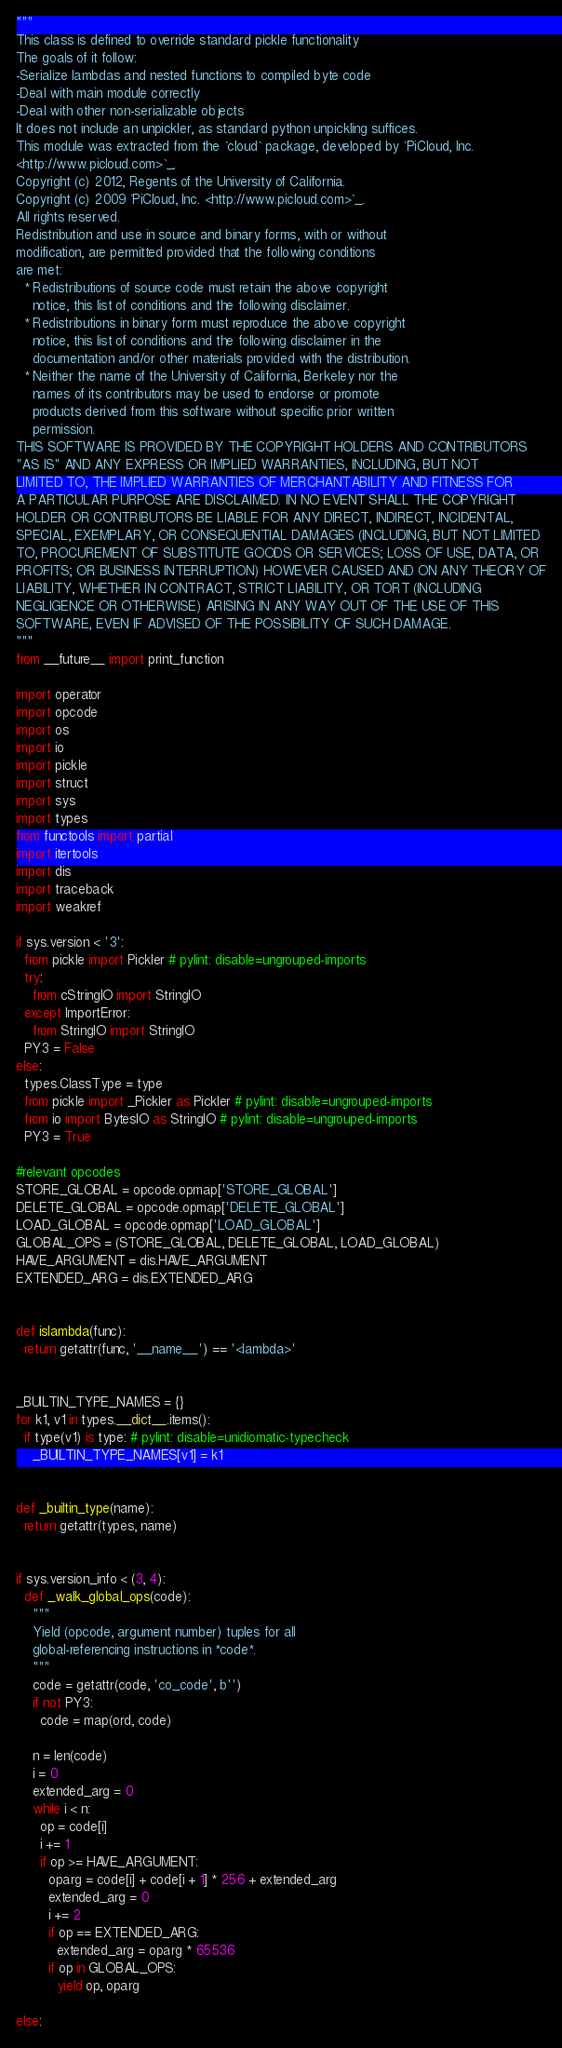<code> <loc_0><loc_0><loc_500><loc_500><_Python_>"""
This class is defined to override standard pickle functionality
The goals of it follow:
-Serialize lambdas and nested functions to compiled byte code
-Deal with main module correctly
-Deal with other non-serializable objects
It does not include an unpickler, as standard python unpickling suffices.
This module was extracted from the `cloud` package, developed by `PiCloud, Inc.
<http://www.picloud.com>`_.
Copyright (c) 2012, Regents of the University of California.
Copyright (c) 2009 `PiCloud, Inc. <http://www.picloud.com>`_.
All rights reserved.
Redistribution and use in source and binary forms, with or without
modification, are permitted provided that the following conditions
are met:
  * Redistributions of source code must retain the above copyright
    notice, this list of conditions and the following disclaimer.
  * Redistributions in binary form must reproduce the above copyright
    notice, this list of conditions and the following disclaimer in the
    documentation and/or other materials provided with the distribution.
  * Neither the name of the University of California, Berkeley nor the
    names of its contributors may be used to endorse or promote
    products derived from this software without specific prior written
    permission.
THIS SOFTWARE IS PROVIDED BY THE COPYRIGHT HOLDERS AND CONTRIBUTORS
"AS IS" AND ANY EXPRESS OR IMPLIED WARRANTIES, INCLUDING, BUT NOT
LIMITED TO, THE IMPLIED WARRANTIES OF MERCHANTABILITY AND FITNESS FOR
A PARTICULAR PURPOSE ARE DISCLAIMED. IN NO EVENT SHALL THE COPYRIGHT
HOLDER OR CONTRIBUTORS BE LIABLE FOR ANY DIRECT, INDIRECT, INCIDENTAL,
SPECIAL, EXEMPLARY, OR CONSEQUENTIAL DAMAGES (INCLUDING, BUT NOT LIMITED
TO, PROCUREMENT OF SUBSTITUTE GOODS OR SERVICES; LOSS OF USE, DATA, OR
PROFITS; OR BUSINESS INTERRUPTION) HOWEVER CAUSED AND ON ANY THEORY OF
LIABILITY, WHETHER IN CONTRACT, STRICT LIABILITY, OR TORT (INCLUDING
NEGLIGENCE OR OTHERWISE) ARISING IN ANY WAY OUT OF THE USE OF THIS
SOFTWARE, EVEN IF ADVISED OF THE POSSIBILITY OF SUCH DAMAGE.
"""
from __future__ import print_function

import operator
import opcode
import os
import io
import pickle
import struct
import sys
import types
from functools import partial
import itertools
import dis
import traceback
import weakref

if sys.version < '3':
  from pickle import Pickler # pylint: disable=ungrouped-imports
  try:
    from cStringIO import StringIO
  except ImportError:
    from StringIO import StringIO
  PY3 = False
else:
  types.ClassType = type
  from pickle import _Pickler as Pickler # pylint: disable=ungrouped-imports
  from io import BytesIO as StringIO # pylint: disable=ungrouped-imports
  PY3 = True

#relevant opcodes
STORE_GLOBAL = opcode.opmap['STORE_GLOBAL']
DELETE_GLOBAL = opcode.opmap['DELETE_GLOBAL']
LOAD_GLOBAL = opcode.opmap['LOAD_GLOBAL']
GLOBAL_OPS = (STORE_GLOBAL, DELETE_GLOBAL, LOAD_GLOBAL)
HAVE_ARGUMENT = dis.HAVE_ARGUMENT
EXTENDED_ARG = dis.EXTENDED_ARG


def islambda(func):
  return getattr(func, '__name__') == '<lambda>'


_BUILTIN_TYPE_NAMES = {}
for k1, v1 in types.__dict__.items():
  if type(v1) is type: # pylint: disable=unidiomatic-typecheck
    _BUILTIN_TYPE_NAMES[v1] = k1


def _builtin_type(name):
  return getattr(types, name)


if sys.version_info < (3, 4):
  def _walk_global_ops(code):
    """
    Yield (opcode, argument number) tuples for all
    global-referencing instructions in *code*.
    """
    code = getattr(code, 'co_code', b'')
    if not PY3:
      code = map(ord, code)

    n = len(code)
    i = 0
    extended_arg = 0
    while i < n:
      op = code[i]
      i += 1
      if op >= HAVE_ARGUMENT:
        oparg = code[i] + code[i + 1] * 256 + extended_arg
        extended_arg = 0
        i += 2
        if op == EXTENDED_ARG:
          extended_arg = oparg * 65536
        if op in GLOBAL_OPS:
          yield op, oparg

else:</code> 